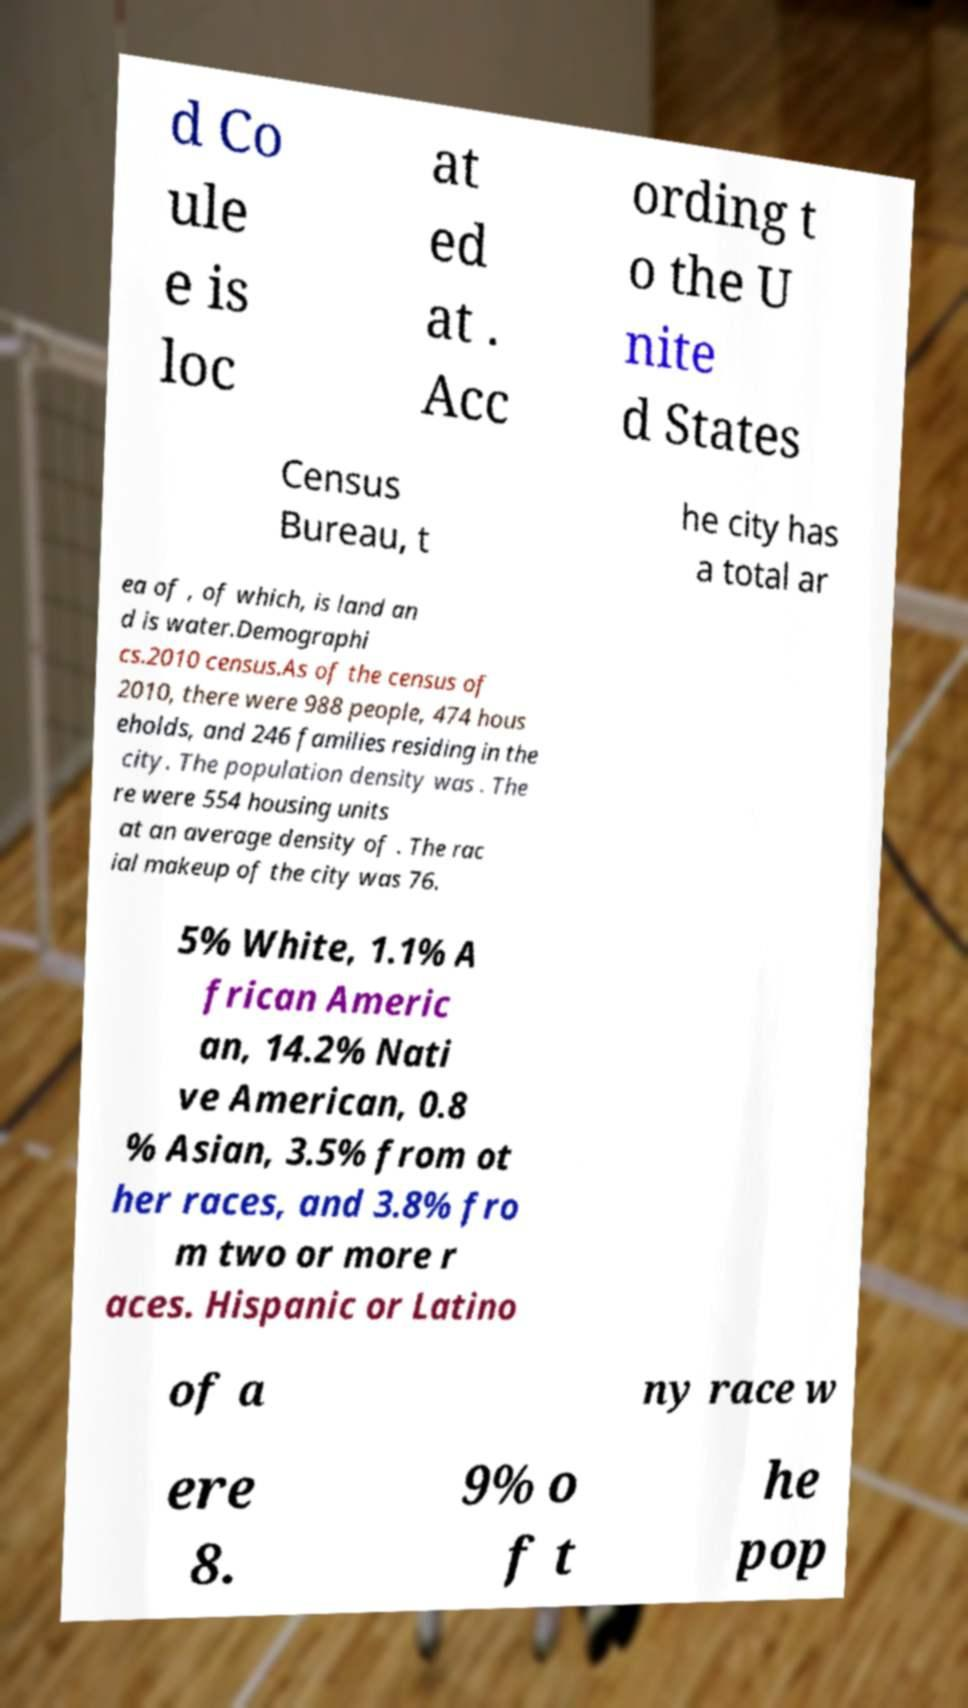There's text embedded in this image that I need extracted. Can you transcribe it verbatim? d Co ule e is loc at ed at . Acc ording t o the U nite d States Census Bureau, t he city has a total ar ea of , of which, is land an d is water.Demographi cs.2010 census.As of the census of 2010, there were 988 people, 474 hous eholds, and 246 families residing in the city. The population density was . The re were 554 housing units at an average density of . The rac ial makeup of the city was 76. 5% White, 1.1% A frican Americ an, 14.2% Nati ve American, 0.8 % Asian, 3.5% from ot her races, and 3.8% fro m two or more r aces. Hispanic or Latino of a ny race w ere 8. 9% o f t he pop 